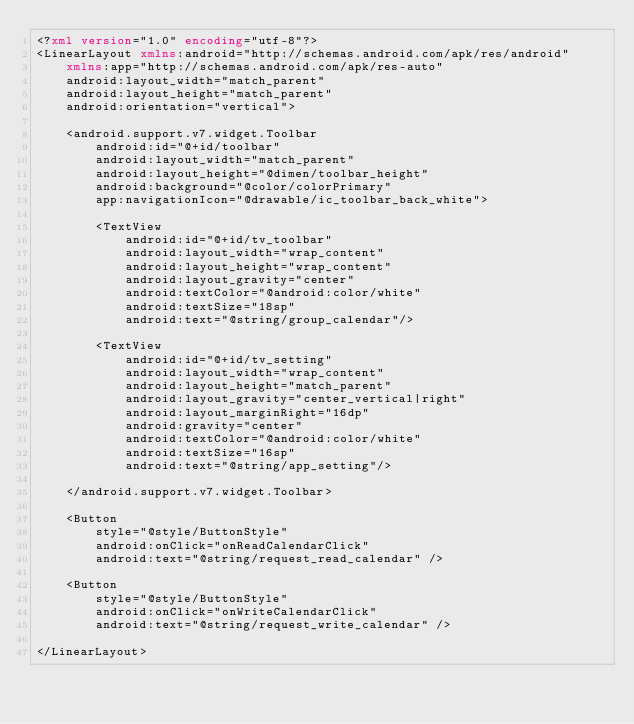<code> <loc_0><loc_0><loc_500><loc_500><_XML_><?xml version="1.0" encoding="utf-8"?>
<LinearLayout xmlns:android="http://schemas.android.com/apk/res/android"
    xmlns:app="http://schemas.android.com/apk/res-auto"
    android:layout_width="match_parent"
    android:layout_height="match_parent"
    android:orientation="vertical">

    <android.support.v7.widget.Toolbar
        android:id="@+id/toolbar"
        android:layout_width="match_parent"
        android:layout_height="@dimen/toolbar_height"
        android:background="@color/colorPrimary"
        app:navigationIcon="@drawable/ic_toolbar_back_white">

        <TextView
            android:id="@+id/tv_toolbar"
            android:layout_width="wrap_content"
            android:layout_height="wrap_content"
            android:layout_gravity="center"
            android:textColor="@android:color/white"
            android:textSize="18sp"
            android:text="@string/group_calendar"/>

        <TextView
            android:id="@+id/tv_setting"
            android:layout_width="wrap_content"
            android:layout_height="match_parent"
            android:layout_gravity="center_vertical|right"
            android:layout_marginRight="16dp"
            android:gravity="center"
            android:textColor="@android:color/white"
            android:textSize="16sp"
            android:text="@string/app_setting"/>

    </android.support.v7.widget.Toolbar>

    <Button
        style="@style/ButtonStyle"
        android:onClick="onReadCalendarClick"
        android:text="@string/request_read_calendar" />

    <Button
        style="@style/ButtonStyle"
        android:onClick="onWriteCalendarClick"
        android:text="@string/request_write_calendar" />

</LinearLayout></code> 